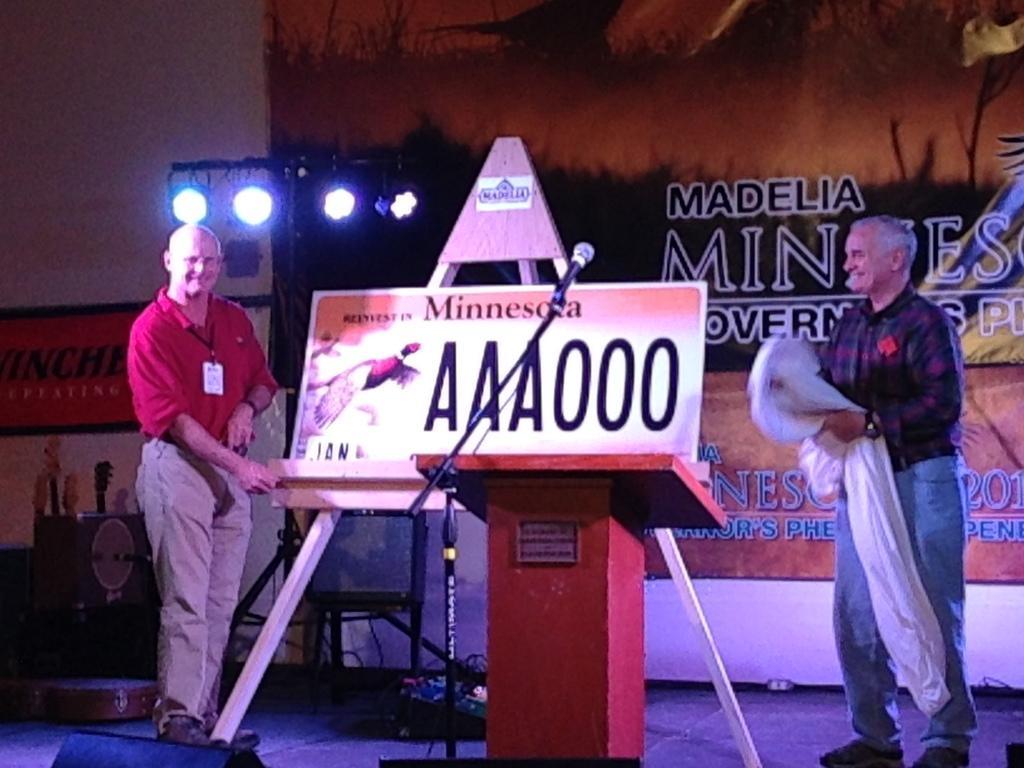Can you describe this image briefly? In this image we can see two people standing. The man standing on the right is holding a cloth in his hand. In the center there is a podium and we can see a mic placed on the stand. In the background there is a board, banner and lights. 